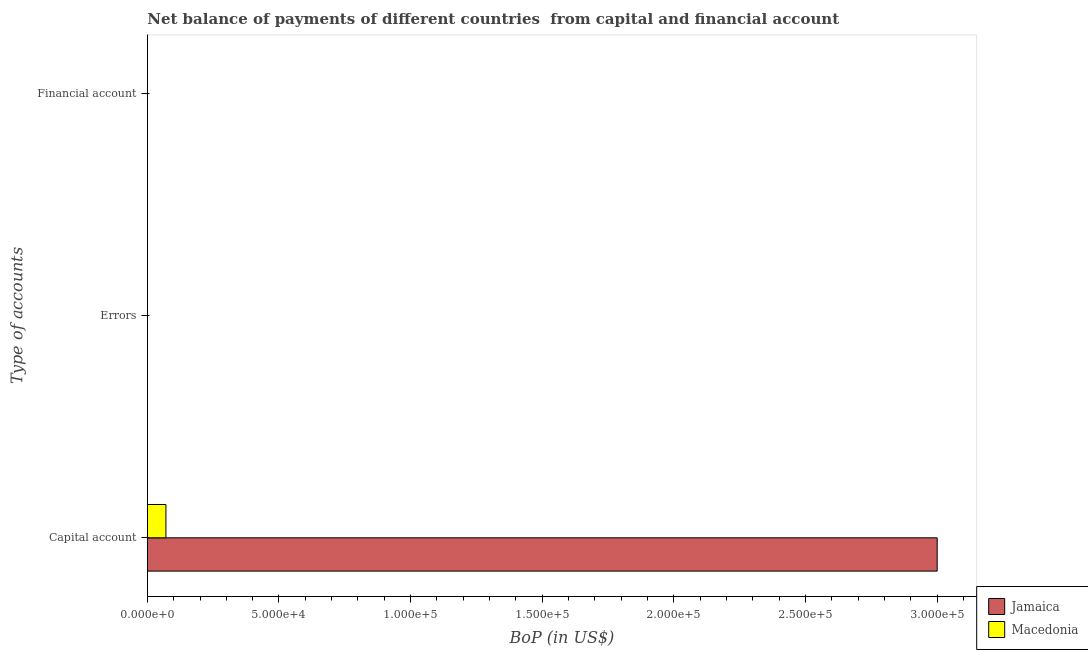How many bars are there on the 1st tick from the top?
Provide a short and direct response. 0. How many bars are there on the 1st tick from the bottom?
Offer a very short reply. 2. What is the label of the 2nd group of bars from the top?
Your answer should be compact. Errors. Across all countries, what is the minimum amount of net capital account?
Give a very brief answer. 7057.87. In which country was the amount of net capital account maximum?
Provide a short and direct response. Jamaica. What is the total amount of net capital account in the graph?
Provide a short and direct response. 3.07e+05. What is the difference between the amount of net capital account in Jamaica and that in Macedonia?
Offer a terse response. 2.93e+05. What is the average amount of errors per country?
Your answer should be very brief. 0. What is the ratio of the amount of net capital account in Jamaica to that in Macedonia?
Your response must be concise. 42.51. Is the amount of net capital account in Macedonia less than that in Jamaica?
Offer a terse response. Yes. What is the difference between the highest and the lowest amount of net capital account?
Keep it short and to the point. 2.93e+05. Is the sum of the amount of net capital account in Jamaica and Macedonia greater than the maximum amount of errors across all countries?
Keep it short and to the point. Yes. How many bars are there?
Your answer should be compact. 2. What is the difference between two consecutive major ticks on the X-axis?
Offer a very short reply. 5.00e+04. What is the title of the graph?
Offer a terse response. Net balance of payments of different countries  from capital and financial account. Does "Belgium" appear as one of the legend labels in the graph?
Give a very brief answer. No. What is the label or title of the X-axis?
Give a very brief answer. BoP (in US$). What is the label or title of the Y-axis?
Offer a very short reply. Type of accounts. What is the BoP (in US$) of Jamaica in Capital account?
Ensure brevity in your answer.  3.00e+05. What is the BoP (in US$) of Macedonia in Capital account?
Provide a succinct answer. 7057.87. What is the BoP (in US$) of Jamaica in Errors?
Ensure brevity in your answer.  0. What is the BoP (in US$) of Macedonia in Errors?
Provide a short and direct response. 0. What is the BoP (in US$) in Jamaica in Financial account?
Offer a very short reply. 0. Across all Type of accounts, what is the maximum BoP (in US$) of Jamaica?
Keep it short and to the point. 3.00e+05. Across all Type of accounts, what is the maximum BoP (in US$) in Macedonia?
Make the answer very short. 7057.87. Across all Type of accounts, what is the minimum BoP (in US$) in Jamaica?
Provide a short and direct response. 0. What is the total BoP (in US$) of Macedonia in the graph?
Ensure brevity in your answer.  7057.87. What is the average BoP (in US$) in Jamaica per Type of accounts?
Provide a short and direct response. 1.00e+05. What is the average BoP (in US$) of Macedonia per Type of accounts?
Offer a very short reply. 2352.62. What is the difference between the BoP (in US$) in Jamaica and BoP (in US$) in Macedonia in Capital account?
Keep it short and to the point. 2.93e+05. What is the difference between the highest and the lowest BoP (in US$) of Macedonia?
Keep it short and to the point. 7057.87. 